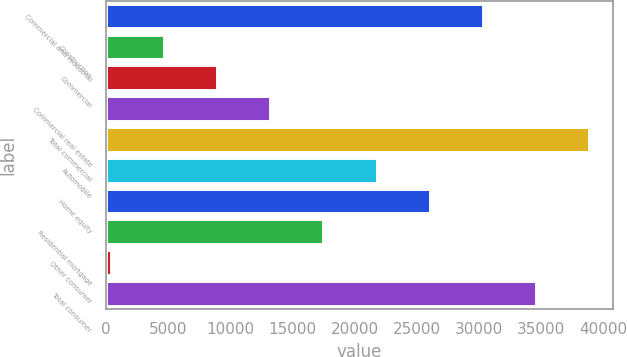<chart> <loc_0><loc_0><loc_500><loc_500><bar_chart><fcel>Commercial and industrial<fcel>Construction<fcel>Commercial<fcel>Commercial real estate<fcel>Total commercial<fcel>Automobile<fcel>Home equity<fcel>Residential mortgage<fcel>Other consumer<fcel>Total consumer<nl><fcel>30298<fcel>4654<fcel>8928<fcel>13202<fcel>38846<fcel>21750<fcel>26024<fcel>17476<fcel>380<fcel>34572<nl></chart> 